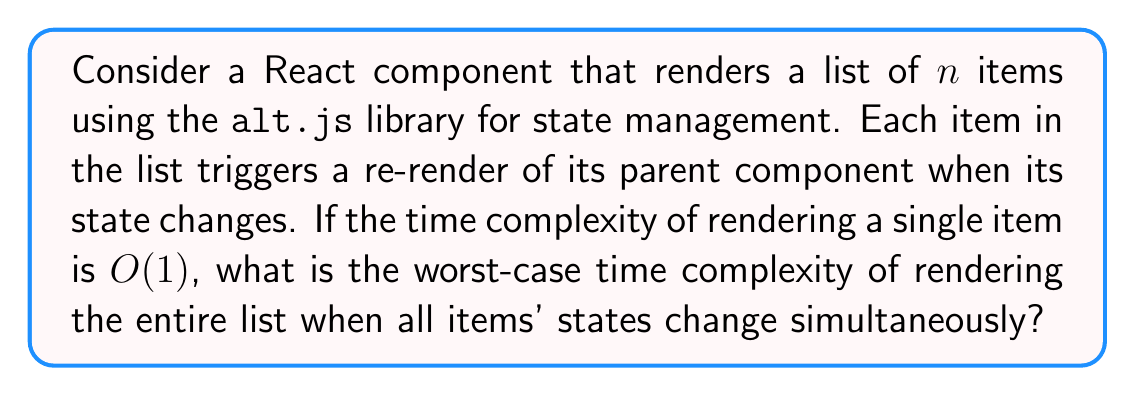Help me with this question. Let's approach this step-by-step:

1) First, we need to understand that each item in the list is rendered independently.

2) The time complexity of rendering a single item is given as $O(1)$, which means it takes constant time regardless of the input size.

3) There are $n$ items in the list, and in the worst-case scenario, all of them need to be re-rendered.

4) When using `alt.js` for state management in React, changes in the state of child components trigger a re-render of their parent component.

5) In this case, when all $n$ items change their state simultaneously, it will trigger $n$ re-renders of the parent component.

6) Each re-render of the parent component will involve rendering all $n$ items again.

7) This creates a nested loop situation:
   - Outer loop: $n$ re-renders of the parent
   - Inner loop: $n$ items rendered in each parent re-render

8) The time complexity can be expressed as:

   $$T(n) = n \times (n \times O(1)) = n \times n \times O(1) = O(n^2)$$

Therefore, the worst-case time complexity of rendering the entire list when all items' states change simultaneously is $O(n^2)$.
Answer: $O(n^2)$ 